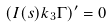<formula> <loc_0><loc_0><loc_500><loc_500>( I ( s ) k _ { 3 } { \Gamma } ) ^ { \prime } = 0</formula> 